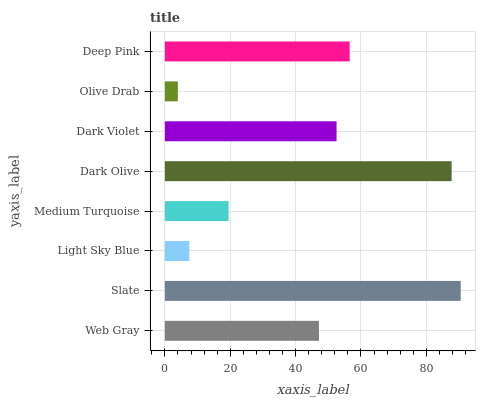Is Olive Drab the minimum?
Answer yes or no. Yes. Is Slate the maximum?
Answer yes or no. Yes. Is Light Sky Blue the minimum?
Answer yes or no. No. Is Light Sky Blue the maximum?
Answer yes or no. No. Is Slate greater than Light Sky Blue?
Answer yes or no. Yes. Is Light Sky Blue less than Slate?
Answer yes or no. Yes. Is Light Sky Blue greater than Slate?
Answer yes or no. No. Is Slate less than Light Sky Blue?
Answer yes or no. No. Is Dark Violet the high median?
Answer yes or no. Yes. Is Web Gray the low median?
Answer yes or no. Yes. Is Olive Drab the high median?
Answer yes or no. No. Is Olive Drab the low median?
Answer yes or no. No. 